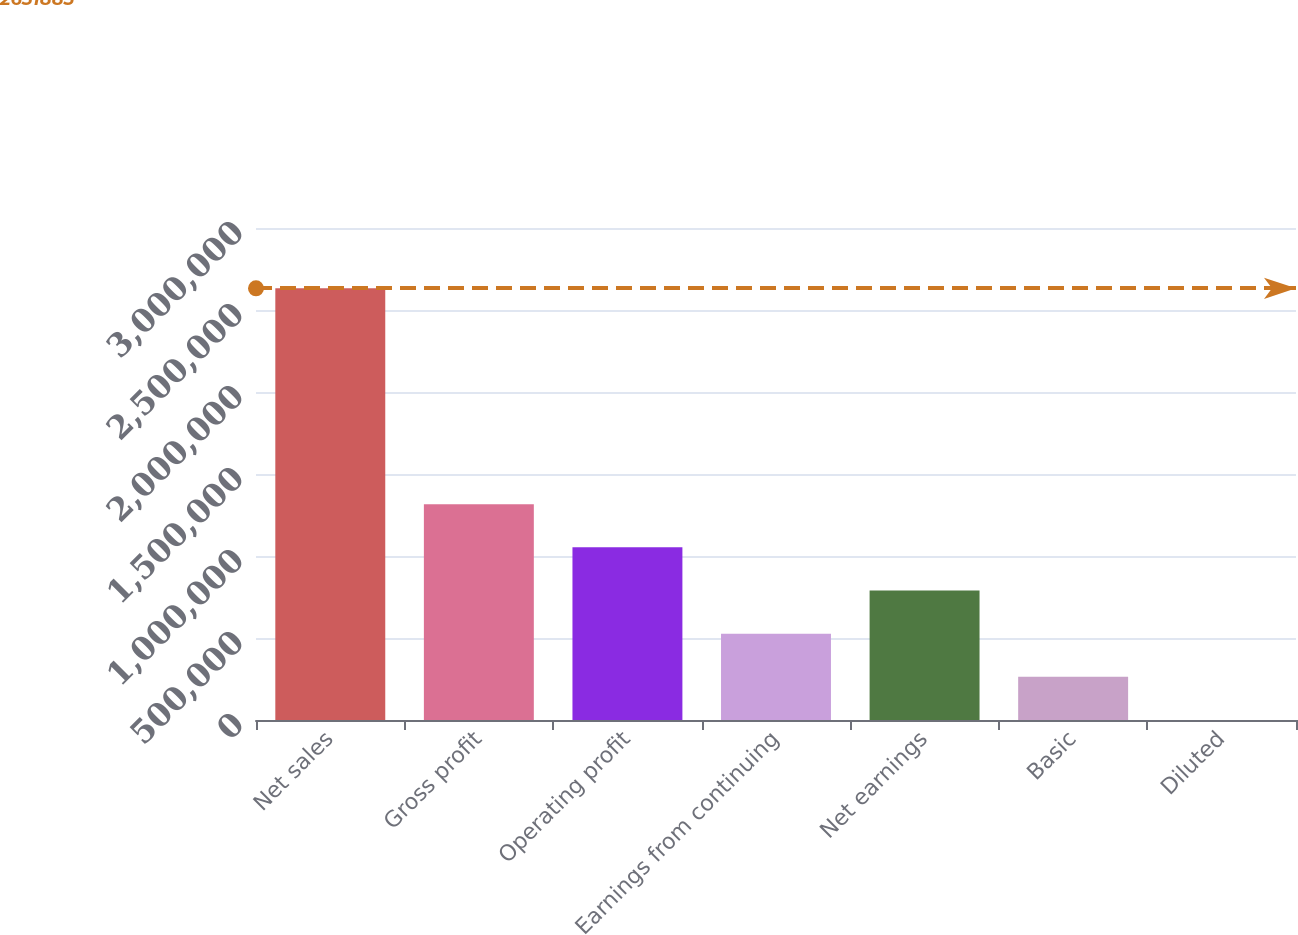Convert chart to OTSL. <chart><loc_0><loc_0><loc_500><loc_500><bar_chart><fcel>Net sales<fcel>Gross profit<fcel>Operating profit<fcel>Earnings from continuing<fcel>Net earnings<fcel>Basic<fcel>Diluted<nl><fcel>2.63188e+06<fcel>1.31594e+06<fcel>1.05275e+06<fcel>526378<fcel>789566<fcel>263189<fcel>0.95<nl></chart> 